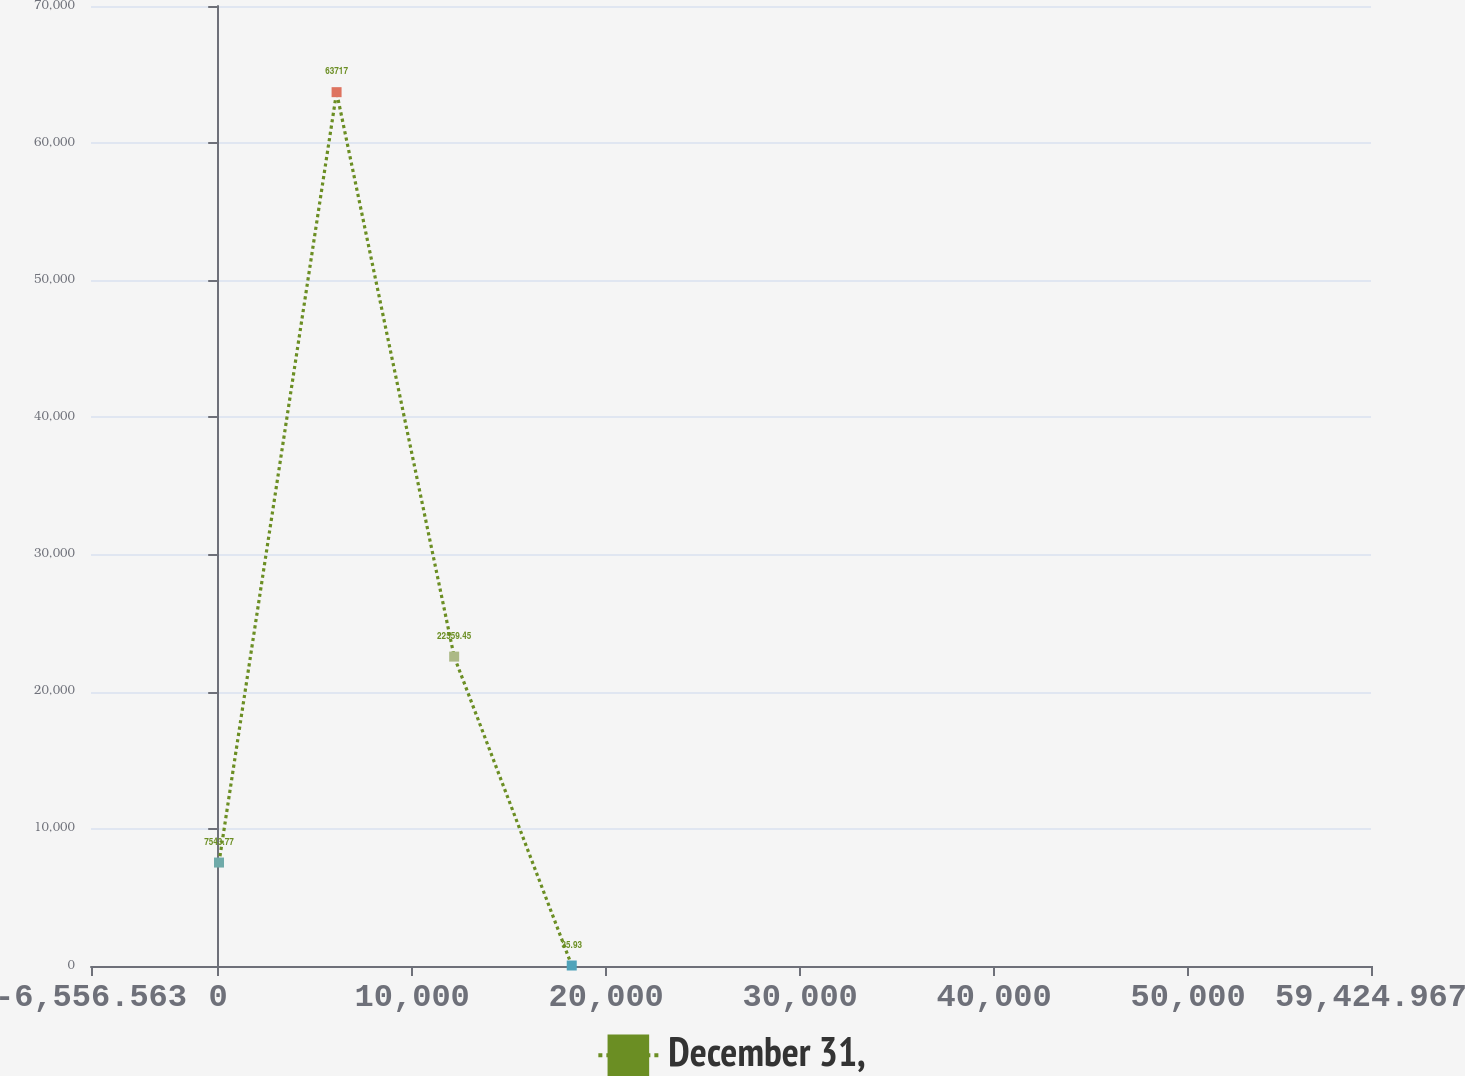Convert chart. <chart><loc_0><loc_0><loc_500><loc_500><line_chart><ecel><fcel>December 31,<nl><fcel>41.59<fcel>7543.77<nl><fcel>6102.72<fcel>63717<nl><fcel>12163.9<fcel>22559.5<nl><fcel>18225<fcel>35.93<nl><fcel>59962<fcel>15051.6<nl><fcel>66023.1<fcel>75114.4<nl></chart> 